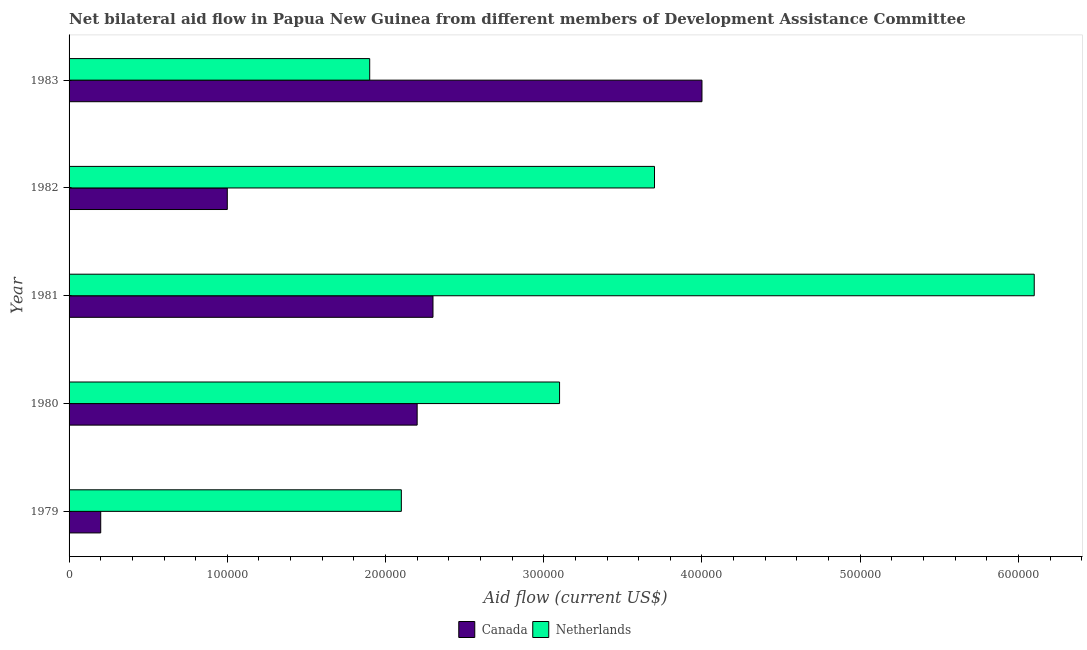How many groups of bars are there?
Your answer should be very brief. 5. Are the number of bars on each tick of the Y-axis equal?
Your response must be concise. Yes. How many bars are there on the 4th tick from the bottom?
Your response must be concise. 2. What is the label of the 3rd group of bars from the top?
Provide a succinct answer. 1981. What is the amount of aid given by netherlands in 1982?
Ensure brevity in your answer.  3.70e+05. Across all years, what is the maximum amount of aid given by canada?
Your answer should be compact. 4.00e+05. Across all years, what is the minimum amount of aid given by canada?
Keep it short and to the point. 2.00e+04. In which year was the amount of aid given by netherlands minimum?
Your answer should be compact. 1983. What is the total amount of aid given by canada in the graph?
Provide a short and direct response. 9.70e+05. What is the difference between the amount of aid given by netherlands in 1979 and that in 1981?
Your response must be concise. -4.00e+05. What is the difference between the amount of aid given by netherlands in 1983 and the amount of aid given by canada in 1979?
Give a very brief answer. 1.70e+05. What is the average amount of aid given by netherlands per year?
Your answer should be compact. 3.38e+05. In the year 1980, what is the difference between the amount of aid given by canada and amount of aid given by netherlands?
Provide a short and direct response. -9.00e+04. What is the ratio of the amount of aid given by netherlands in 1981 to that in 1983?
Provide a succinct answer. 3.21. Is the amount of aid given by canada in 1981 less than that in 1983?
Offer a terse response. Yes. Is the difference between the amount of aid given by canada in 1982 and 1983 greater than the difference between the amount of aid given by netherlands in 1982 and 1983?
Provide a succinct answer. No. What is the difference between the highest and the lowest amount of aid given by canada?
Make the answer very short. 3.80e+05. In how many years, is the amount of aid given by canada greater than the average amount of aid given by canada taken over all years?
Provide a short and direct response. 3. Is the sum of the amount of aid given by netherlands in 1980 and 1981 greater than the maximum amount of aid given by canada across all years?
Offer a terse response. Yes. Are all the bars in the graph horizontal?
Your answer should be very brief. Yes. What is the difference between two consecutive major ticks on the X-axis?
Provide a short and direct response. 1.00e+05. Does the graph contain grids?
Ensure brevity in your answer.  No. Where does the legend appear in the graph?
Make the answer very short. Bottom center. What is the title of the graph?
Make the answer very short. Net bilateral aid flow in Papua New Guinea from different members of Development Assistance Committee. Does "Not attending school" appear as one of the legend labels in the graph?
Your answer should be compact. No. What is the label or title of the Y-axis?
Your answer should be compact. Year. What is the Aid flow (current US$) in Netherlands in 1982?
Ensure brevity in your answer.  3.70e+05. What is the Aid flow (current US$) in Netherlands in 1983?
Provide a short and direct response. 1.90e+05. Across all years, what is the maximum Aid flow (current US$) of Netherlands?
Your answer should be compact. 6.10e+05. Across all years, what is the minimum Aid flow (current US$) in Canada?
Provide a short and direct response. 2.00e+04. Across all years, what is the minimum Aid flow (current US$) of Netherlands?
Offer a very short reply. 1.90e+05. What is the total Aid flow (current US$) of Canada in the graph?
Give a very brief answer. 9.70e+05. What is the total Aid flow (current US$) of Netherlands in the graph?
Make the answer very short. 1.69e+06. What is the difference between the Aid flow (current US$) of Canada in 1979 and that in 1981?
Offer a terse response. -2.10e+05. What is the difference between the Aid flow (current US$) of Netherlands in 1979 and that in 1981?
Ensure brevity in your answer.  -4.00e+05. What is the difference between the Aid flow (current US$) of Canada in 1979 and that in 1982?
Keep it short and to the point. -8.00e+04. What is the difference between the Aid flow (current US$) of Netherlands in 1979 and that in 1982?
Your answer should be compact. -1.60e+05. What is the difference between the Aid flow (current US$) in Canada in 1979 and that in 1983?
Offer a very short reply. -3.80e+05. What is the difference between the Aid flow (current US$) in Canada in 1980 and that in 1981?
Offer a terse response. -10000. What is the difference between the Aid flow (current US$) of Netherlands in 1980 and that in 1981?
Offer a very short reply. -3.00e+05. What is the difference between the Aid flow (current US$) in Canada in 1980 and that in 1982?
Keep it short and to the point. 1.20e+05. What is the difference between the Aid flow (current US$) of Canada in 1980 and that in 1983?
Offer a very short reply. -1.80e+05. What is the difference between the Aid flow (current US$) of Canada in 1981 and that in 1982?
Provide a short and direct response. 1.30e+05. What is the difference between the Aid flow (current US$) in Netherlands in 1981 and that in 1982?
Your answer should be compact. 2.40e+05. What is the difference between the Aid flow (current US$) of Netherlands in 1981 and that in 1983?
Your answer should be compact. 4.20e+05. What is the difference between the Aid flow (current US$) of Canada in 1982 and that in 1983?
Offer a very short reply. -3.00e+05. What is the difference between the Aid flow (current US$) of Canada in 1979 and the Aid flow (current US$) of Netherlands in 1980?
Offer a terse response. -2.90e+05. What is the difference between the Aid flow (current US$) of Canada in 1979 and the Aid flow (current US$) of Netherlands in 1981?
Give a very brief answer. -5.90e+05. What is the difference between the Aid flow (current US$) in Canada in 1979 and the Aid flow (current US$) in Netherlands in 1982?
Your answer should be compact. -3.50e+05. What is the difference between the Aid flow (current US$) of Canada in 1979 and the Aid flow (current US$) of Netherlands in 1983?
Give a very brief answer. -1.70e+05. What is the difference between the Aid flow (current US$) in Canada in 1980 and the Aid flow (current US$) in Netherlands in 1981?
Offer a very short reply. -3.90e+05. What is the difference between the Aid flow (current US$) in Canada in 1980 and the Aid flow (current US$) in Netherlands in 1982?
Your response must be concise. -1.50e+05. What is the difference between the Aid flow (current US$) of Canada in 1980 and the Aid flow (current US$) of Netherlands in 1983?
Make the answer very short. 3.00e+04. What is the difference between the Aid flow (current US$) in Canada in 1981 and the Aid flow (current US$) in Netherlands in 1982?
Your answer should be compact. -1.40e+05. What is the difference between the Aid flow (current US$) of Canada in 1981 and the Aid flow (current US$) of Netherlands in 1983?
Ensure brevity in your answer.  4.00e+04. What is the difference between the Aid flow (current US$) in Canada in 1982 and the Aid flow (current US$) in Netherlands in 1983?
Make the answer very short. -9.00e+04. What is the average Aid flow (current US$) of Canada per year?
Offer a very short reply. 1.94e+05. What is the average Aid flow (current US$) of Netherlands per year?
Provide a succinct answer. 3.38e+05. In the year 1980, what is the difference between the Aid flow (current US$) in Canada and Aid flow (current US$) in Netherlands?
Offer a very short reply. -9.00e+04. In the year 1981, what is the difference between the Aid flow (current US$) in Canada and Aid flow (current US$) in Netherlands?
Make the answer very short. -3.80e+05. In the year 1983, what is the difference between the Aid flow (current US$) in Canada and Aid flow (current US$) in Netherlands?
Make the answer very short. 2.10e+05. What is the ratio of the Aid flow (current US$) in Canada in 1979 to that in 1980?
Offer a terse response. 0.09. What is the ratio of the Aid flow (current US$) in Netherlands in 1979 to that in 1980?
Offer a very short reply. 0.68. What is the ratio of the Aid flow (current US$) in Canada in 1979 to that in 1981?
Make the answer very short. 0.09. What is the ratio of the Aid flow (current US$) in Netherlands in 1979 to that in 1981?
Offer a terse response. 0.34. What is the ratio of the Aid flow (current US$) in Netherlands in 1979 to that in 1982?
Keep it short and to the point. 0.57. What is the ratio of the Aid flow (current US$) in Netherlands in 1979 to that in 1983?
Offer a very short reply. 1.11. What is the ratio of the Aid flow (current US$) of Canada in 1980 to that in 1981?
Your answer should be compact. 0.96. What is the ratio of the Aid flow (current US$) of Netherlands in 1980 to that in 1981?
Keep it short and to the point. 0.51. What is the ratio of the Aid flow (current US$) of Canada in 1980 to that in 1982?
Your answer should be very brief. 2.2. What is the ratio of the Aid flow (current US$) in Netherlands in 1980 to that in 1982?
Keep it short and to the point. 0.84. What is the ratio of the Aid flow (current US$) of Canada in 1980 to that in 1983?
Provide a short and direct response. 0.55. What is the ratio of the Aid flow (current US$) in Netherlands in 1980 to that in 1983?
Your answer should be very brief. 1.63. What is the ratio of the Aid flow (current US$) in Canada in 1981 to that in 1982?
Your answer should be compact. 2.3. What is the ratio of the Aid flow (current US$) in Netherlands in 1981 to that in 1982?
Keep it short and to the point. 1.65. What is the ratio of the Aid flow (current US$) in Canada in 1981 to that in 1983?
Provide a succinct answer. 0.57. What is the ratio of the Aid flow (current US$) of Netherlands in 1981 to that in 1983?
Provide a succinct answer. 3.21. What is the ratio of the Aid flow (current US$) in Netherlands in 1982 to that in 1983?
Offer a terse response. 1.95. What is the difference between the highest and the second highest Aid flow (current US$) of Canada?
Keep it short and to the point. 1.70e+05. What is the difference between the highest and the lowest Aid flow (current US$) in Netherlands?
Your response must be concise. 4.20e+05. 